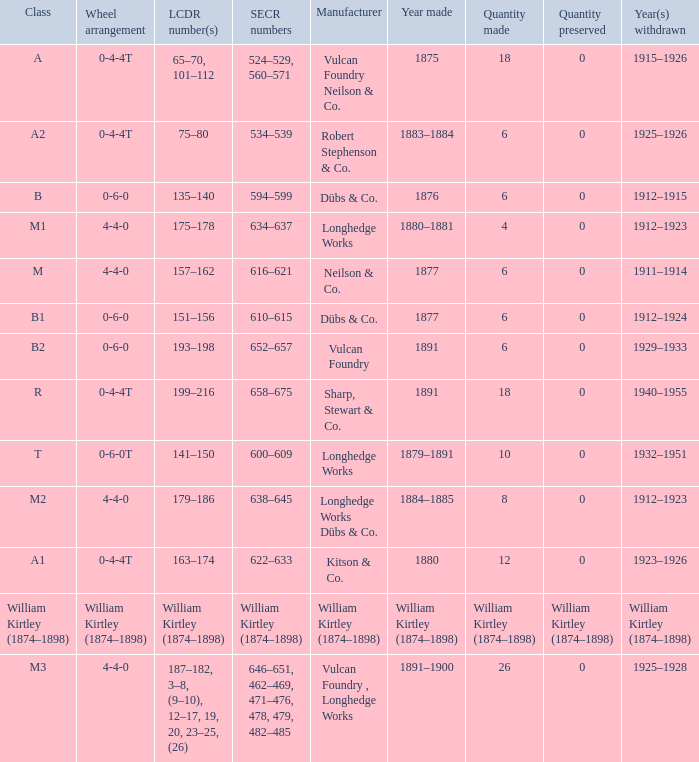Which SECR numbers have a class of b1? 610–615. 